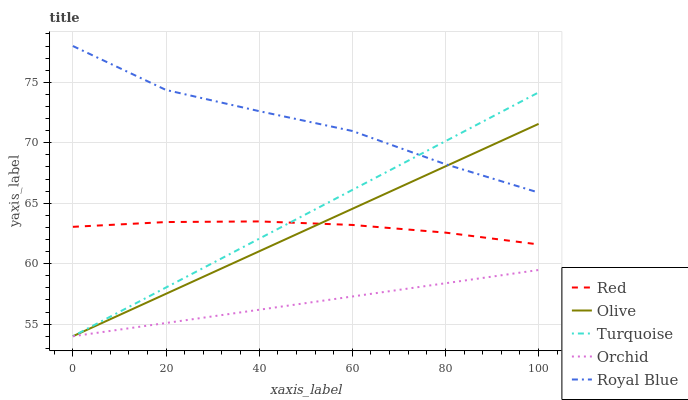Does Orchid have the minimum area under the curve?
Answer yes or no. Yes. Does Royal Blue have the maximum area under the curve?
Answer yes or no. Yes. Does Turquoise have the minimum area under the curve?
Answer yes or no. No. Does Turquoise have the maximum area under the curve?
Answer yes or no. No. Is Turquoise the smoothest?
Answer yes or no. Yes. Is Royal Blue the roughest?
Answer yes or no. Yes. Is Royal Blue the smoothest?
Answer yes or no. No. Is Turquoise the roughest?
Answer yes or no. No. Does Royal Blue have the lowest value?
Answer yes or no. No. Does Royal Blue have the highest value?
Answer yes or no. Yes. Does Turquoise have the highest value?
Answer yes or no. No. Is Orchid less than Royal Blue?
Answer yes or no. Yes. Is Red greater than Orchid?
Answer yes or no. Yes. Does Royal Blue intersect Turquoise?
Answer yes or no. Yes. Is Royal Blue less than Turquoise?
Answer yes or no. No. Is Royal Blue greater than Turquoise?
Answer yes or no. No. Does Orchid intersect Royal Blue?
Answer yes or no. No. 